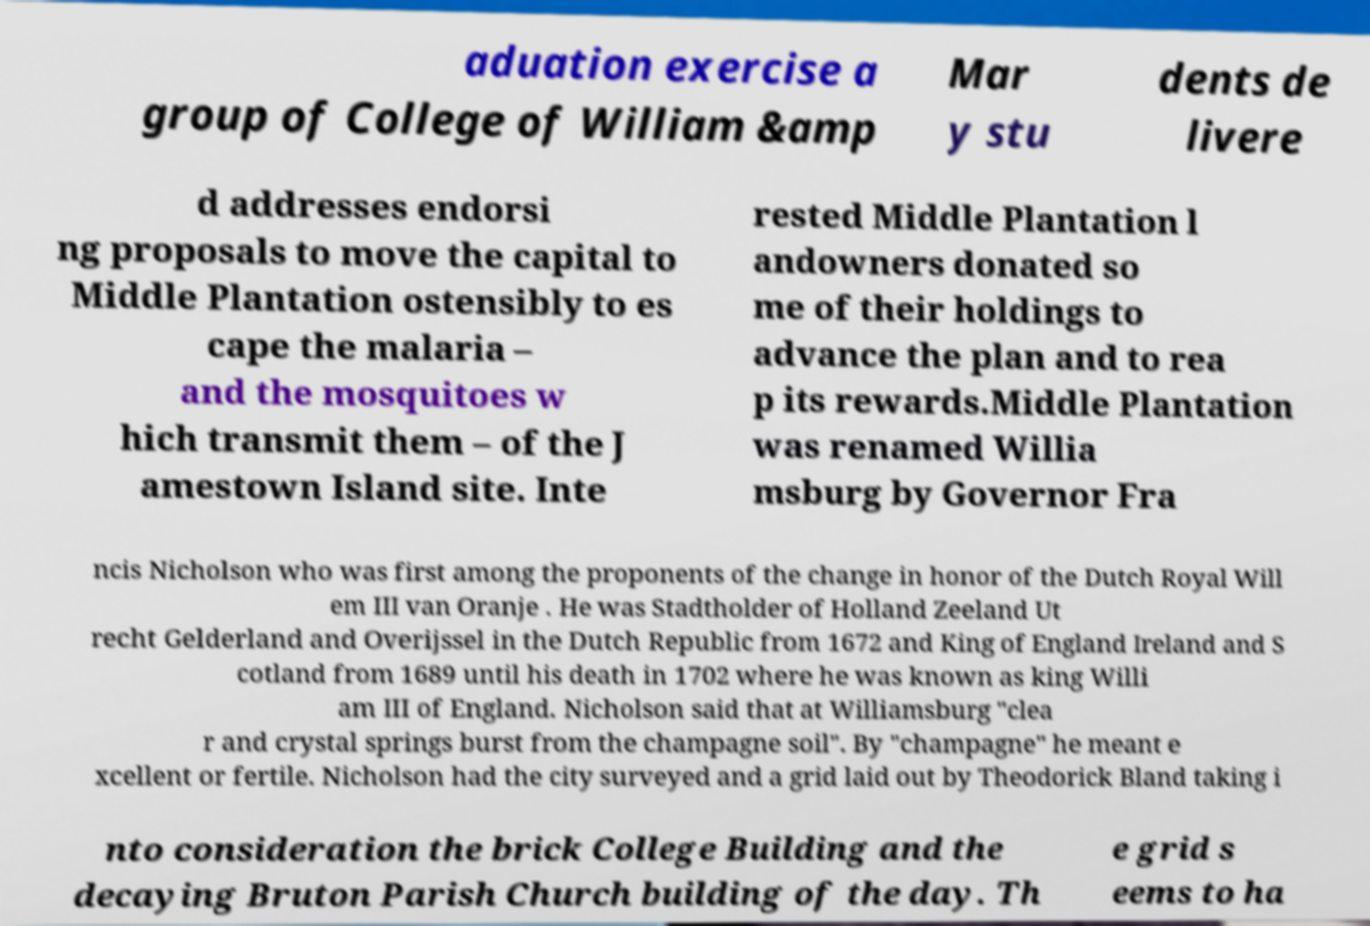Can you accurately transcribe the text from the provided image for me? aduation exercise a group of College of William &amp Mar y stu dents de livere d addresses endorsi ng proposals to move the capital to Middle Plantation ostensibly to es cape the malaria – and the mosquitoes w hich transmit them – of the J amestown Island site. Inte rested Middle Plantation l andowners donated so me of their holdings to advance the plan and to rea p its rewards.Middle Plantation was renamed Willia msburg by Governor Fra ncis Nicholson who was first among the proponents of the change in honor of the Dutch Royal Will em III van Oranje . He was Stadtholder of Holland Zeeland Ut recht Gelderland and Overijssel in the Dutch Republic from 1672 and King of England Ireland and S cotland from 1689 until his death in 1702 where he was known as king Willi am III of England. Nicholson said that at Williamsburg "clea r and crystal springs burst from the champagne soil". By "champagne" he meant e xcellent or fertile. Nicholson had the city surveyed and a grid laid out by Theodorick Bland taking i nto consideration the brick College Building and the decaying Bruton Parish Church building of the day. Th e grid s eems to ha 